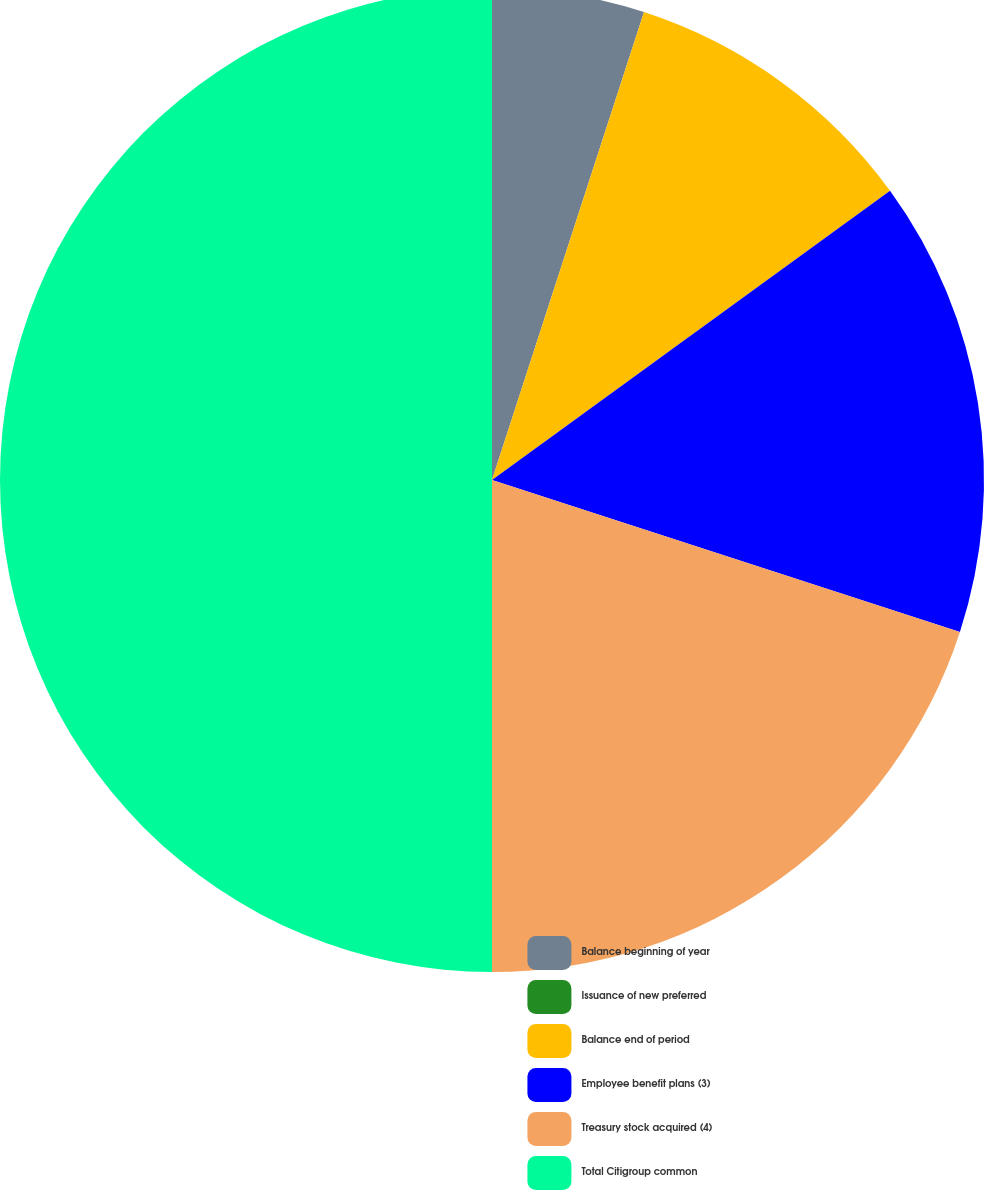Convert chart to OTSL. <chart><loc_0><loc_0><loc_500><loc_500><pie_chart><fcel>Balance beginning of year<fcel>Issuance of new preferred<fcel>Balance end of period<fcel>Employee benefit plans (3)<fcel>Treasury stock acquired (4)<fcel>Total Citigroup common<nl><fcel>5.0%<fcel>0.0%<fcel>10.0%<fcel>15.0%<fcel>20.0%<fcel>50.0%<nl></chart> 